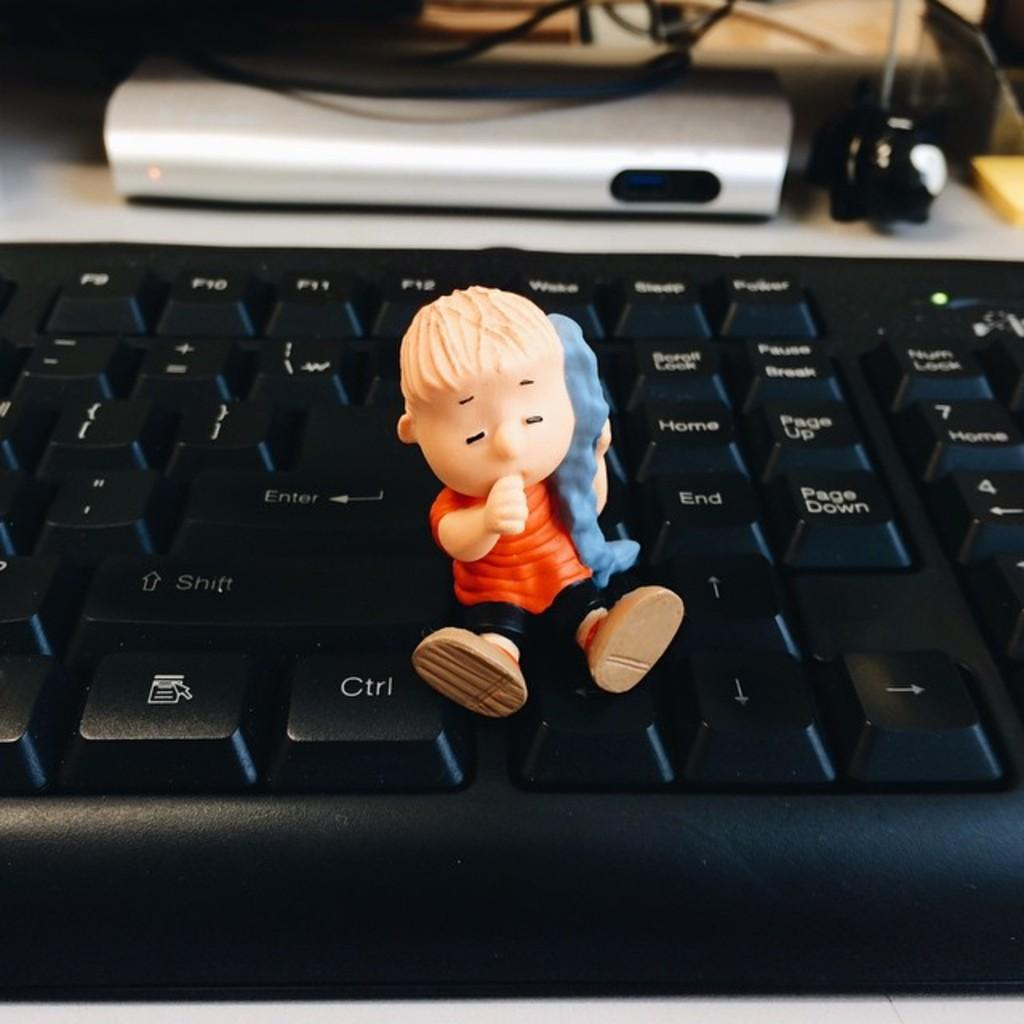<image>
Present a compact description of the photo's key features. A small figurine of a child sitting on a laptop with one foot on the CTRL key. 